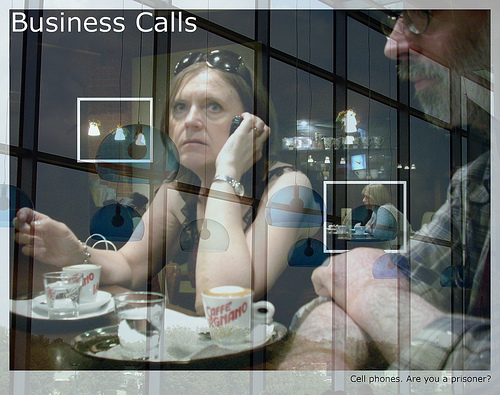Is the man on the left of the picture? No, the man is not on the left of the picture. 